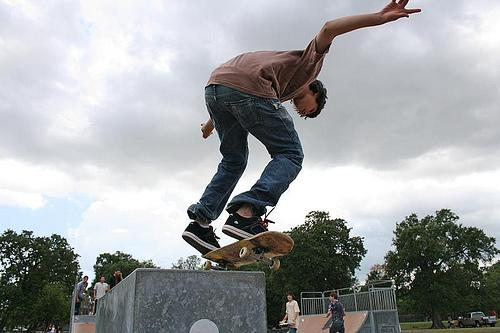What is the best material for a skateboard? wood 